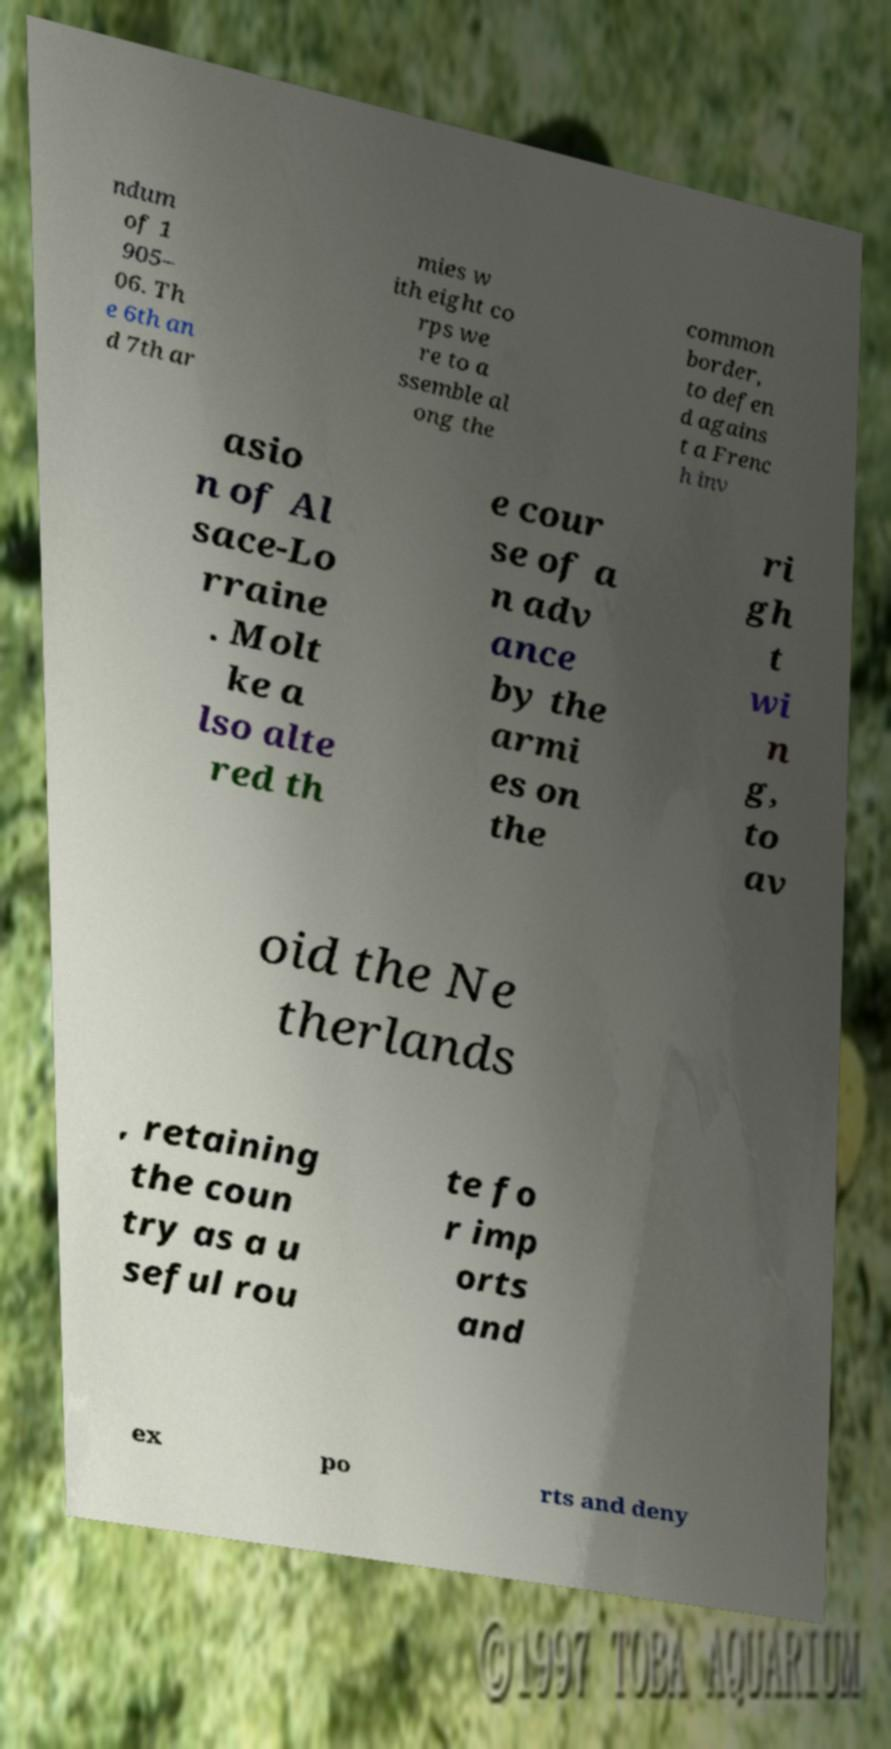I need the written content from this picture converted into text. Can you do that? ndum of 1 905– 06. Th e 6th an d 7th ar mies w ith eight co rps we re to a ssemble al ong the common border, to defen d agains t a Frenc h inv asio n of Al sace-Lo rraine . Molt ke a lso alte red th e cour se of a n adv ance by the armi es on the ri gh t wi n g, to av oid the Ne therlands , retaining the coun try as a u seful rou te fo r imp orts and ex po rts and deny 